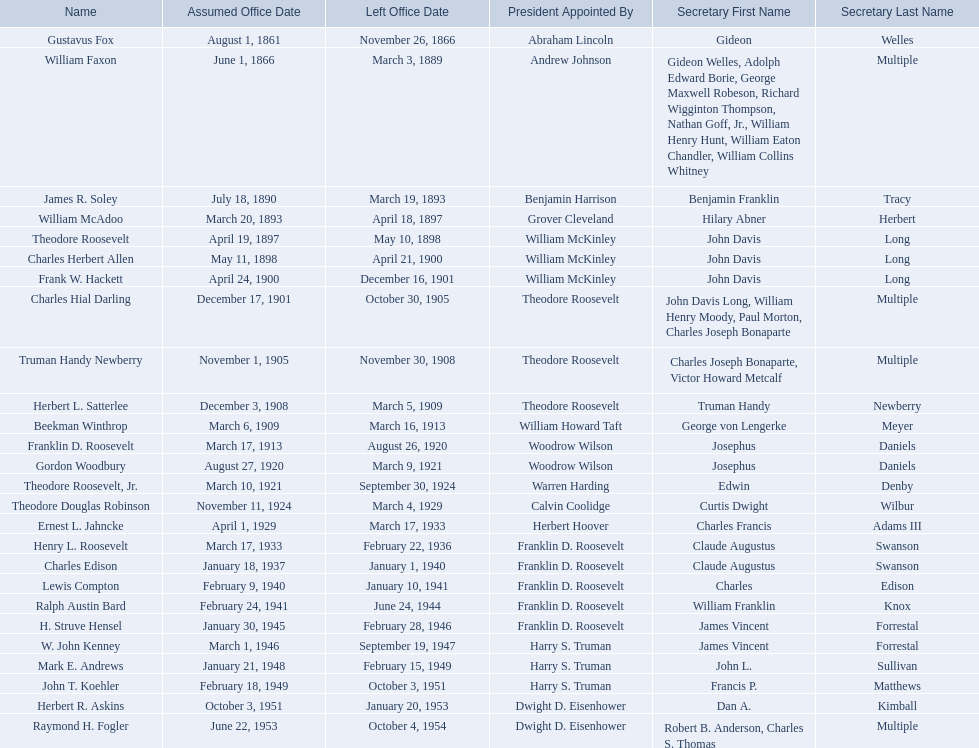Help me parse the entirety of this table. {'header': ['Name', 'Assumed Office Date', 'Left Office Date', 'President Appointed By', 'Secretary First Name', 'Secretary Last Name'], 'rows': [['Gustavus Fox', 'August 1, 1861', 'November 26, 1866', 'Abraham Lincoln', 'Gideon', 'Welles'], ['William Faxon', 'June 1, 1866', 'March 3, 1889', 'Andrew Johnson', 'Gideon Welles, Adolph Edward Borie, George Maxwell Robeson, Richard Wigginton Thompson, Nathan Goff, Jr., William Henry Hunt, William Eaton Chandler, William Collins Whitney', 'Multiple'], ['James R. Soley', 'July 18, 1890', 'March 19, 1893', 'Benjamin Harrison', 'Benjamin Franklin', 'Tracy'], ['William McAdoo', 'March 20, 1893', 'April 18, 1897', 'Grover Cleveland', 'Hilary Abner', 'Herbert'], ['Theodore Roosevelt', 'April 19, 1897', 'May 10, 1898', 'William McKinley', 'John Davis', 'Long'], ['Charles Herbert Allen', 'May 11, 1898', 'April 21, 1900', 'William McKinley', 'John Davis', 'Long'], ['Frank W. Hackett', 'April 24, 1900', 'December 16, 1901', 'William McKinley', 'John Davis', 'Long'], ['Charles Hial Darling', 'December 17, 1901', 'October 30, 1905', 'Theodore Roosevelt', 'John Davis Long, William Henry Moody, Paul Morton, Charles Joseph Bonaparte', 'Multiple'], ['Truman Handy Newberry', 'November 1, 1905', 'November 30, 1908', 'Theodore Roosevelt', 'Charles Joseph Bonaparte, Victor Howard Metcalf', 'Multiple'], ['Herbert L. Satterlee', 'December 3, 1908', 'March 5, 1909', 'Theodore Roosevelt', 'Truman Handy', 'Newberry'], ['Beekman Winthrop', 'March 6, 1909', 'March 16, 1913', 'William Howard Taft', 'George von Lengerke', 'Meyer'], ['Franklin D. Roosevelt', 'March 17, 1913', 'August 26, 1920', 'Woodrow Wilson', 'Josephus', 'Daniels'], ['Gordon Woodbury', 'August 27, 1920', 'March 9, 1921', 'Woodrow Wilson', 'Josephus', 'Daniels'], ['Theodore Roosevelt, Jr.', 'March 10, 1921', 'September 30, 1924', 'Warren Harding', 'Edwin', 'Denby'], ['Theodore Douglas Robinson', 'November 11, 1924', 'March 4, 1929', 'Calvin Coolidge', 'Curtis Dwight', 'Wilbur'], ['Ernest L. Jahncke', 'April 1, 1929', 'March 17, 1933', 'Herbert Hoover', 'Charles Francis', 'Adams III'], ['Henry L. Roosevelt', 'March 17, 1933', 'February 22, 1936', 'Franklin D. Roosevelt', 'Claude Augustus', 'Swanson'], ['Charles Edison', 'January 18, 1937', 'January 1, 1940', 'Franklin D. Roosevelt', 'Claude Augustus', 'Swanson'], ['Lewis Compton', 'February 9, 1940', 'January 10, 1941', 'Franklin D. Roosevelt', 'Charles', 'Edison'], ['Ralph Austin Bard', 'February 24, 1941', 'June 24, 1944', 'Franklin D. Roosevelt', 'William Franklin', 'Knox'], ['H. Struve Hensel', 'January 30, 1945', 'February 28, 1946', 'Franklin D. Roosevelt', 'James Vincent', 'Forrestal'], ['W. John Kenney', 'March 1, 1946', 'September 19, 1947', 'Harry S. Truman', 'James Vincent', 'Forrestal'], ['Mark E. Andrews', 'January 21, 1948', 'February 15, 1949', 'Harry S. Truman', 'John L.', 'Sullivan'], ['John T. Koehler', 'February 18, 1949', 'October 3, 1951', 'Harry S. Truman', 'Francis P.', 'Matthews'], ['Herbert R. Askins', 'October 3, 1951', 'January 20, 1953', 'Dwight D. Eisenhower', 'Dan A.', 'Kimball'], ['Raymond H. Fogler', 'June 22, 1953', 'October 4, 1954', 'Dwight D. Eisenhower', 'Robert B. Anderson, Charles S. Thomas', 'Multiple']]} Who were all the assistant secretary's of the navy? Gustavus Fox, William Faxon, James R. Soley, William McAdoo, Theodore Roosevelt, Charles Herbert Allen, Frank W. Hackett, Charles Hial Darling, Truman Handy Newberry, Herbert L. Satterlee, Beekman Winthrop, Franklin D. Roosevelt, Gordon Woodbury, Theodore Roosevelt, Jr., Theodore Douglas Robinson, Ernest L. Jahncke, Henry L. Roosevelt, Charles Edison, Lewis Compton, Ralph Austin Bard, H. Struve Hensel, W. John Kenney, Mark E. Andrews, John T. Koehler, Herbert R. Askins, Raymond H. Fogler. What are the various dates they left office in? November 26, 1866, March 3, 1889, March 19, 1893, April 18, 1897, May 10, 1898, April 21, 1900, December 16, 1901, October 30, 1905, November 30, 1908, March 5, 1909, March 16, 1913, August 26, 1920, March 9, 1921, September 30, 1924, March 4, 1929, March 17, 1933, February 22, 1936, January 1, 1940, January 10, 1941, June 24, 1944, February 28, 1946, September 19, 1947, February 15, 1949, October 3, 1951, January 20, 1953, October 4, 1954. Of these dates, which was the date raymond h. fogler left office in? October 4, 1954. 